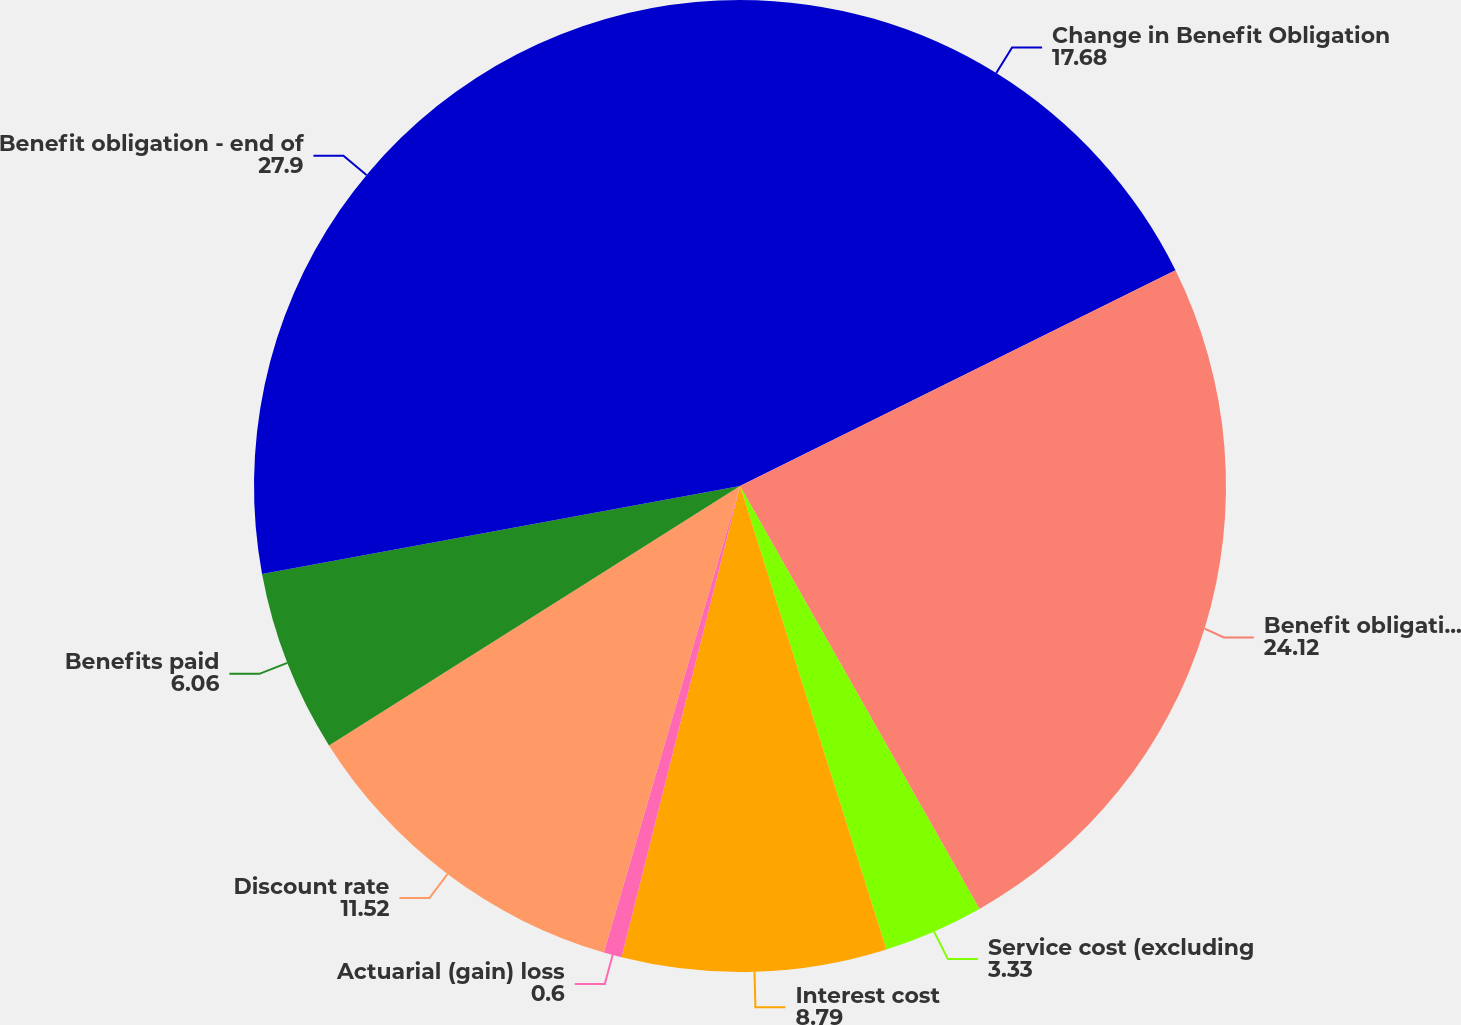Convert chart to OTSL. <chart><loc_0><loc_0><loc_500><loc_500><pie_chart><fcel>Change in Benefit Obligation<fcel>Benefit obligation - beginning<fcel>Service cost (excluding<fcel>Interest cost<fcel>Actuarial (gain) loss<fcel>Discount rate<fcel>Benefits paid<fcel>Benefit obligation - end of<nl><fcel>17.68%<fcel>24.12%<fcel>3.33%<fcel>8.79%<fcel>0.6%<fcel>11.52%<fcel>6.06%<fcel>27.9%<nl></chart> 